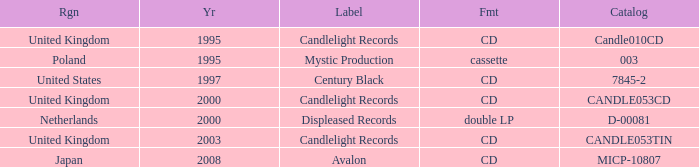What was the candlelight records catalog of candle053tin structure? CD. 